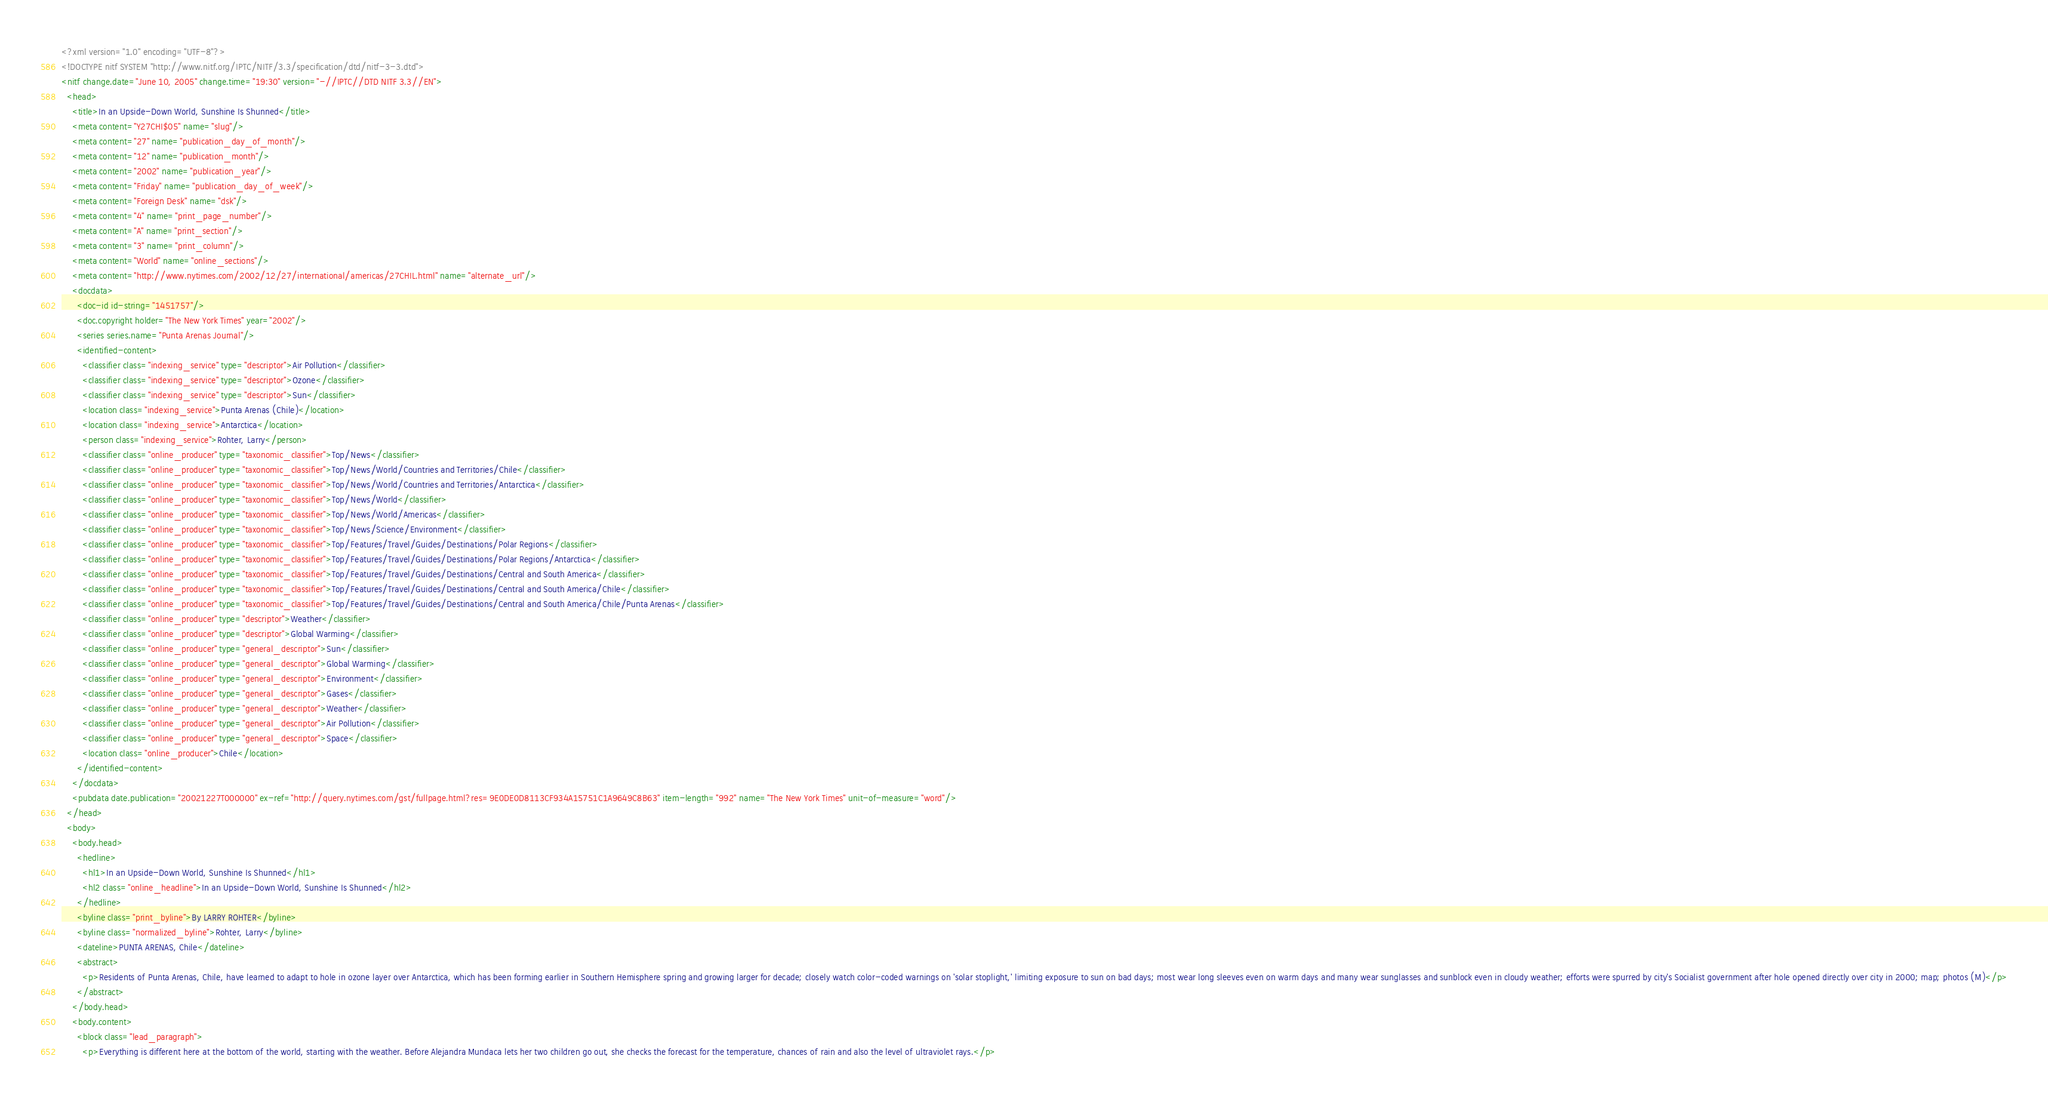Convert code to text. <code><loc_0><loc_0><loc_500><loc_500><_XML_><?xml version="1.0" encoding="UTF-8"?>
<!DOCTYPE nitf SYSTEM "http://www.nitf.org/IPTC/NITF/3.3/specification/dtd/nitf-3-3.dtd">
<nitf change.date="June 10, 2005" change.time="19:30" version="-//IPTC//DTD NITF 3.3//EN">
  <head>
    <title>In an Upside-Down World, Sunshine Is Shunned</title>
    <meta content="Y27CHI$05" name="slug"/>
    <meta content="27" name="publication_day_of_month"/>
    <meta content="12" name="publication_month"/>
    <meta content="2002" name="publication_year"/>
    <meta content="Friday" name="publication_day_of_week"/>
    <meta content="Foreign Desk" name="dsk"/>
    <meta content="4" name="print_page_number"/>
    <meta content="A" name="print_section"/>
    <meta content="3" name="print_column"/>
    <meta content="World" name="online_sections"/>
    <meta content="http://www.nytimes.com/2002/12/27/international/americas/27CHIL.html" name="alternate_url"/>
    <docdata>
      <doc-id id-string="1451757"/>
      <doc.copyright holder="The New York Times" year="2002"/>
      <series series.name="Punta Arenas Journal"/>
      <identified-content>
        <classifier class="indexing_service" type="descriptor">Air Pollution</classifier>
        <classifier class="indexing_service" type="descriptor">Ozone</classifier>
        <classifier class="indexing_service" type="descriptor">Sun</classifier>
        <location class="indexing_service">Punta Arenas (Chile)</location>
        <location class="indexing_service">Antarctica</location>
        <person class="indexing_service">Rohter, Larry</person>
        <classifier class="online_producer" type="taxonomic_classifier">Top/News</classifier>
        <classifier class="online_producer" type="taxonomic_classifier">Top/News/World/Countries and Territories/Chile</classifier>
        <classifier class="online_producer" type="taxonomic_classifier">Top/News/World/Countries and Territories/Antarctica</classifier>
        <classifier class="online_producer" type="taxonomic_classifier">Top/News/World</classifier>
        <classifier class="online_producer" type="taxonomic_classifier">Top/News/World/Americas</classifier>
        <classifier class="online_producer" type="taxonomic_classifier">Top/News/Science/Environment</classifier>
        <classifier class="online_producer" type="taxonomic_classifier">Top/Features/Travel/Guides/Destinations/Polar Regions</classifier>
        <classifier class="online_producer" type="taxonomic_classifier">Top/Features/Travel/Guides/Destinations/Polar Regions/Antarctica</classifier>
        <classifier class="online_producer" type="taxonomic_classifier">Top/Features/Travel/Guides/Destinations/Central and South America</classifier>
        <classifier class="online_producer" type="taxonomic_classifier">Top/Features/Travel/Guides/Destinations/Central and South America/Chile</classifier>
        <classifier class="online_producer" type="taxonomic_classifier">Top/Features/Travel/Guides/Destinations/Central and South America/Chile/Punta Arenas</classifier>
        <classifier class="online_producer" type="descriptor">Weather</classifier>
        <classifier class="online_producer" type="descriptor">Global Warming</classifier>
        <classifier class="online_producer" type="general_descriptor">Sun</classifier>
        <classifier class="online_producer" type="general_descriptor">Global Warming</classifier>
        <classifier class="online_producer" type="general_descriptor">Environment</classifier>
        <classifier class="online_producer" type="general_descriptor">Gases</classifier>
        <classifier class="online_producer" type="general_descriptor">Weather</classifier>
        <classifier class="online_producer" type="general_descriptor">Air Pollution</classifier>
        <classifier class="online_producer" type="general_descriptor">Space</classifier>
        <location class="online_producer">Chile</location>
      </identified-content>
    </docdata>
    <pubdata date.publication="20021227T000000" ex-ref="http://query.nytimes.com/gst/fullpage.html?res=9E0DE0D8113CF934A15751C1A9649C8B63" item-length="992" name="The New York Times" unit-of-measure="word"/>
  </head>
  <body>
    <body.head>
      <hedline>
        <hl1>In an Upside-Down World, Sunshine Is Shunned</hl1>
        <hl2 class="online_headline">In an Upside-Down World, Sunshine Is Shunned</hl2>
      </hedline>
      <byline class="print_byline">By LARRY ROHTER</byline>
      <byline class="normalized_byline">Rohter, Larry</byline>
      <dateline>PUNTA ARENAS, Chile</dateline>
      <abstract>
        <p>Residents of Punta Arenas, Chile, have learned to adapt to hole in ozone layer over Antarctica, which has been forming earlier in Southern Hemisphere spring and growing larger for decade; closely watch color-coded warnings on 'solar stoplight,' limiting exposure to sun on bad days; most wear long sleeves even on warm days and many wear sunglasses and sunblock even in cloudy weather; efforts were spurred by city's Socialist government after hole opened directly over city in 2000; map; photos (M)</p>
      </abstract>
    </body.head>
    <body.content>
      <block class="lead_paragraph">
        <p>Everything is different here at the bottom of the world, starting with the weather. Before Alejandra Mundaca lets her two children go out, she checks the forecast for the temperature, chances of rain and also the level of ultraviolet rays.</p></code> 